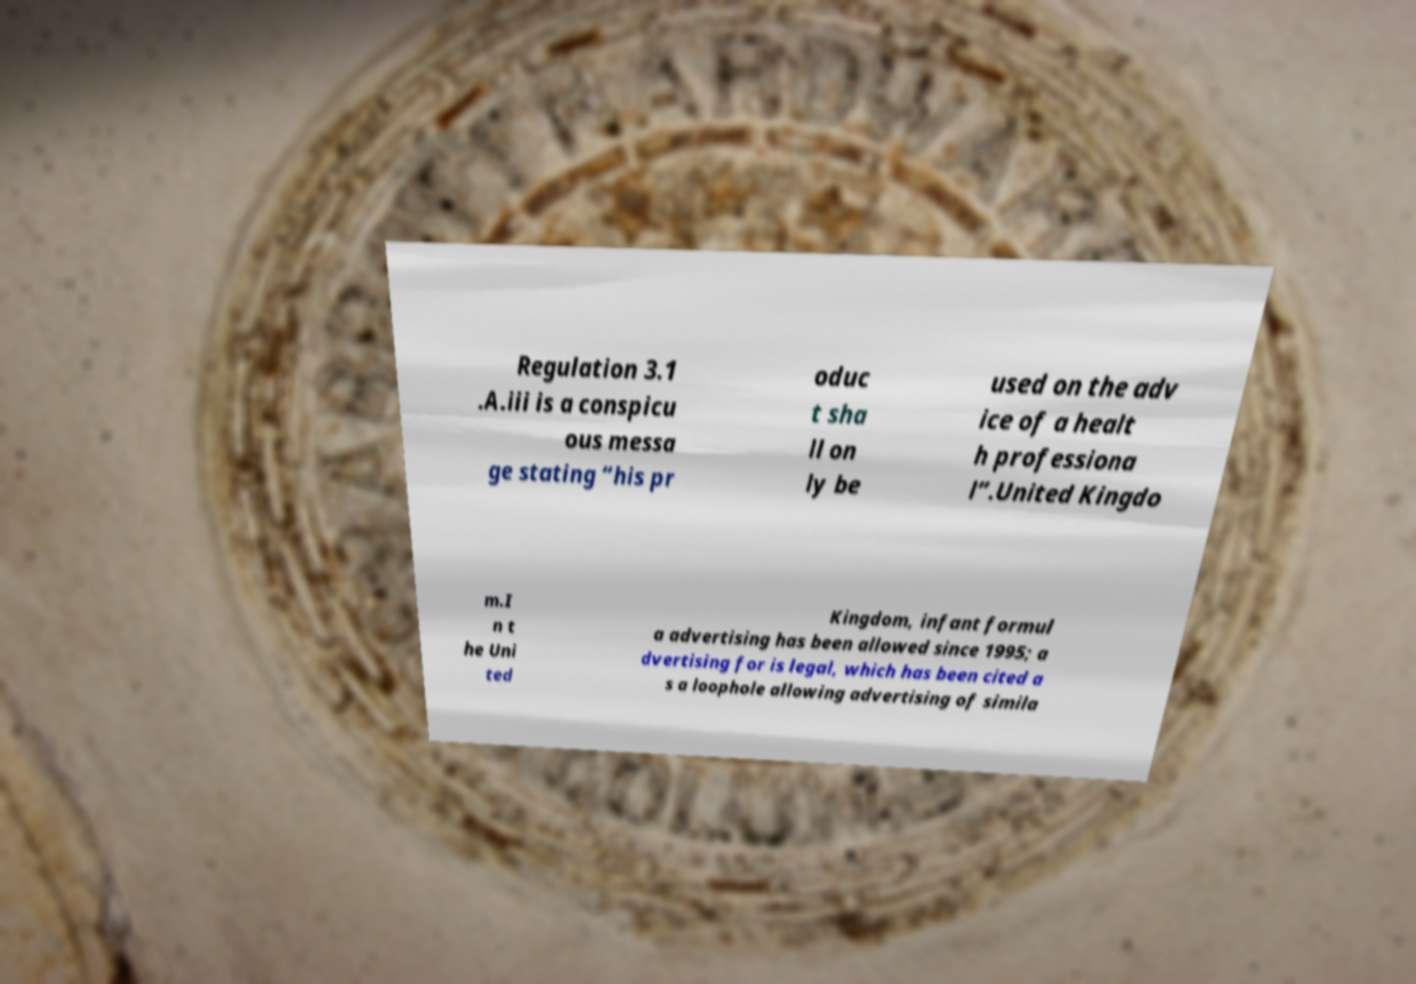There's text embedded in this image that I need extracted. Can you transcribe it verbatim? Regulation 3.1 .A.iii is a conspicu ous messa ge stating “his pr oduc t sha ll on ly be used on the adv ice of a healt h professiona l”.United Kingdo m.I n t he Uni ted Kingdom, infant formul a advertising has been allowed since 1995; a dvertising for is legal, which has been cited a s a loophole allowing advertising of simila 